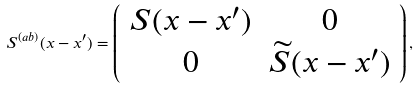<formula> <loc_0><loc_0><loc_500><loc_500>S ^ { ( a b ) } ( x - x ^ { \prime } ) = \left ( \begin{array} { c c } S ( x - x ^ { \prime } ) & 0 \\ 0 & \widetilde { S } ( x - x ^ { \prime } ) \end{array} \right ) ,</formula> 